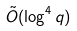Convert formula to latex. <formula><loc_0><loc_0><loc_500><loc_500>\tilde { O } ( \log ^ { 4 } q )</formula> 